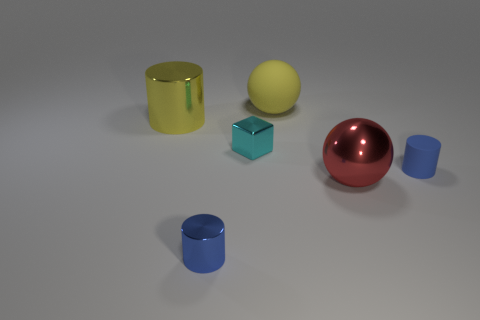What is the shape of the thing that is the same color as the rubber ball?
Ensure brevity in your answer.  Cylinder. What number of spheres are tiny shiny objects or blue metallic things?
Give a very brief answer. 0. How many cyan cubes have the same material as the big red thing?
Offer a very short reply. 1. Is the blue cylinder on the left side of the cyan object made of the same material as the object right of the red sphere?
Offer a very short reply. No. There is a blue object right of the small blue cylinder that is on the left side of the shiny block; what number of big yellow matte balls are in front of it?
Give a very brief answer. 0. Do the big sphere that is in front of the tiny cyan cube and the small object that is on the left side of the cyan metallic thing have the same color?
Your answer should be compact. No. Are there any other things that have the same color as the big matte thing?
Keep it short and to the point. Yes. What color is the tiny object that is right of the sphere behind the tiny cyan cube?
Ensure brevity in your answer.  Blue. Are there any small cylinders?
Offer a terse response. Yes. There is a big thing that is both to the right of the blue shiny cylinder and in front of the large rubber ball; what is its color?
Make the answer very short. Red. 